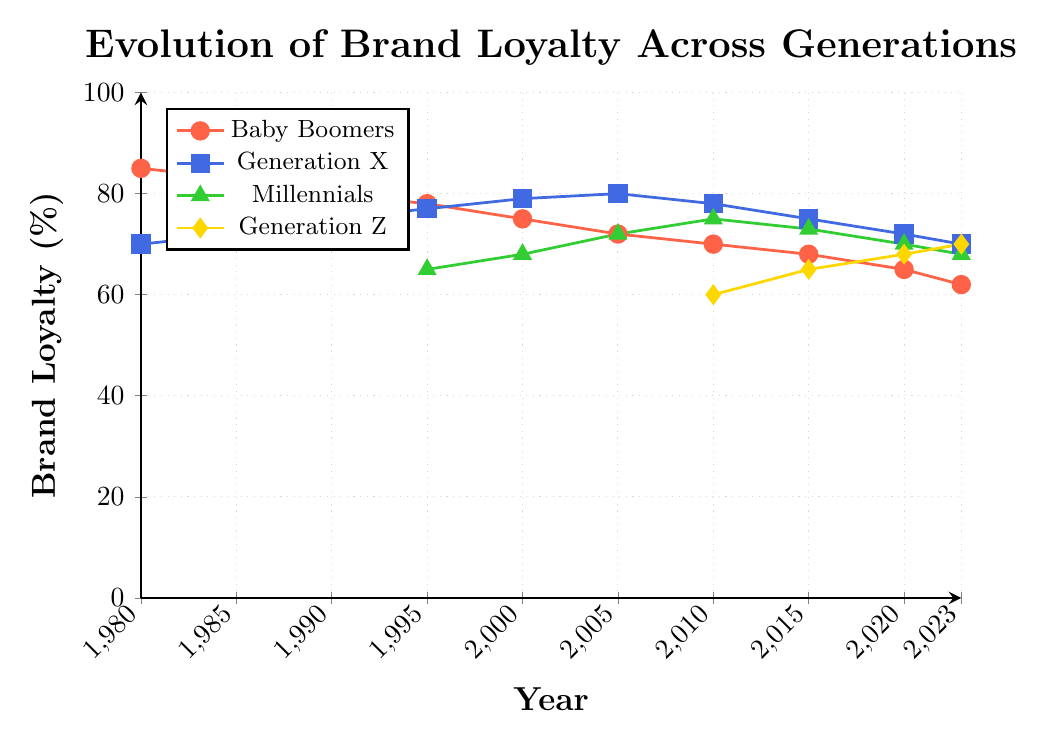What trend can be observed in brand loyalty for Baby Boomers from 1980 to 2023? The brand loyalty for Baby Boomers has been steadily decreasing over the years. Starting at 85% in 1980, it drops to 62% by 2023. This shows a clear downward trend.
Answer: Decreasing Which generation had the highest brand loyalty in 2000, and what was the value? In 2000, Generation X had the highest brand loyalty with a value of 79%. This can be determined by looking at the highest point among the generations in that specific year.
Answer: Generation X, 79% Compare the brand loyalty of Millennials and Generation Z in 2023. Which generation has higher loyalty and by how much? In 2023, the brand loyalty for Millennials is 68%, while for Generation Z, it is 70%. Generation Z has higher loyalty, and the difference is 2%.
Answer: Generation Z, 2% What is the average brand loyalty for Generation X from 1980 to 2023? The values for Generation X over the years are 70, 72, 75, 77, 79, 80, 78, 75, 72, and 70. Summing these up gives 748. Dividing by 10 (number of data points): 748 / 10 = 74.8%.
Answer: 74.8% How does the brand loyalty of Millennials change from 1995 to 2023? Millennial brand loyalty starts at 65% in 1995, rises to a peak of 75% in 2010, then gradually decreases to 68% by 2023.
Answer: Rises to 75% in 2010, then decreases to 68% in 2023 Which generation shows the most stable brand loyalty from their first recorded year to 2023? Stability can be seen by observing fluctuations. Generation X, starting at 70% in 1980 and ending at 70% in 2023, shows the least fluctuation over time.
Answer: Generation X What is the difference in brand loyalty between Baby Boomers and Generation Z in 2023? In 2023, brand loyalty for Baby Boomers is 62% and for Generation Z it is 70%. The difference is 70% - 62% = 8%.
Answer: 8% In which year did Generation Z surpass the brand loyalty of Millennials? Generation Z surpasses Millennials between 2020 and 2023. In 2020, Millennials have 70% and Generation Z has 68%, but in 2023, Generation Z has 70% and Millennials have 68%.
Answer: Between 2020 and 2023 Which generation had the greatest decline in brand loyalty over the span of the given data and by how much? Baby Boomers had the greatest decline, starting at 85% in 1980 and ending at 62% in 2023, a decline of 23%.
Answer: Baby Boomers, 23% By how much did brand loyalty for Generation X change between 1980 and 2005? Initially, Generation X had 70% loyalty in 1980, which increased to 80% by 2005. The change is 80% - 70% = 10%.
Answer: 10% 